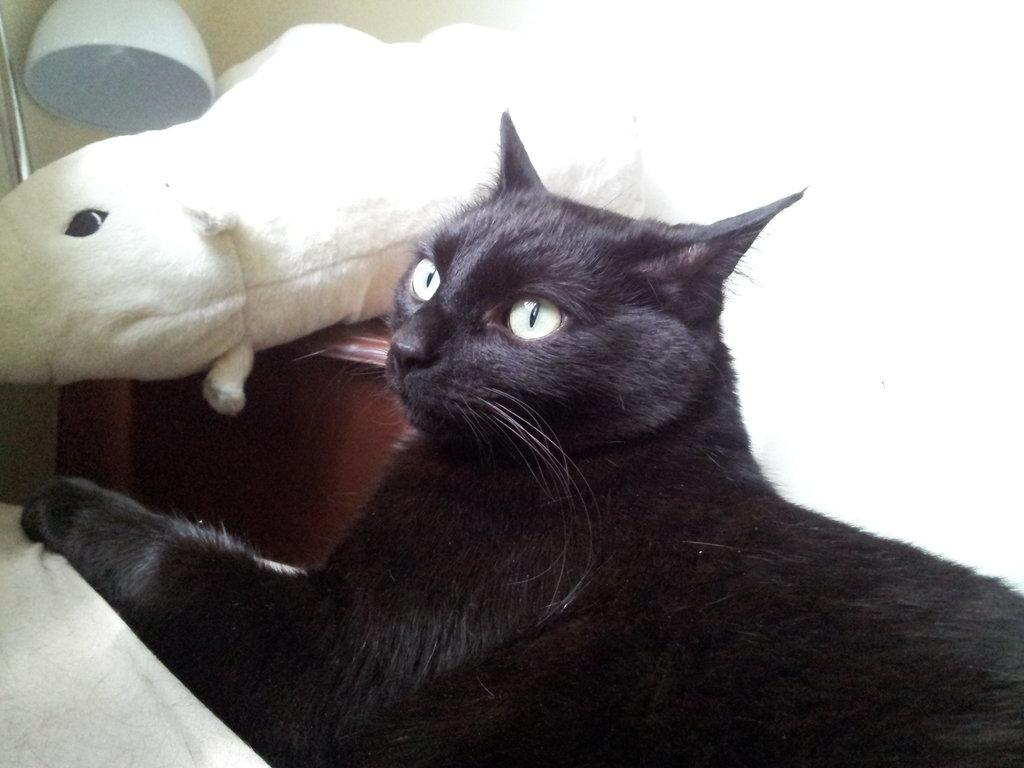What type of animal is in the image? There is a cat in the image. What is located in the bottom left corner of the image? There is a cloth in the bottom left corner of the image. What object can be seen on a table in the image? There is a toy on a table in the image. Where is the lamp positioned in the image? The lamp is in the top left corner of the image. What can be seen in the background of the image? There is a wall visible in the background of the image. What type of mountain is visible in the image? There is no mountain present in the image. What is the cat thinking in the image? It is impossible to determine what the cat is thinking from the image alone. 